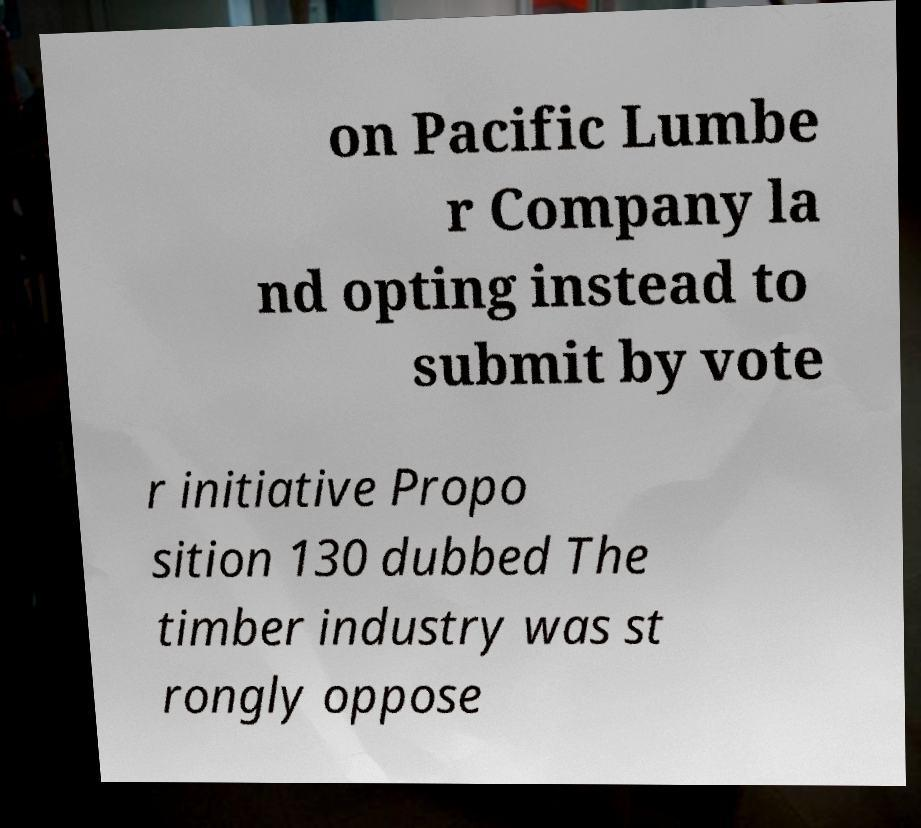Can you read and provide the text displayed in the image?This photo seems to have some interesting text. Can you extract and type it out for me? on Pacific Lumbe r Company la nd opting instead to submit by vote r initiative Propo sition 130 dubbed The timber industry was st rongly oppose 